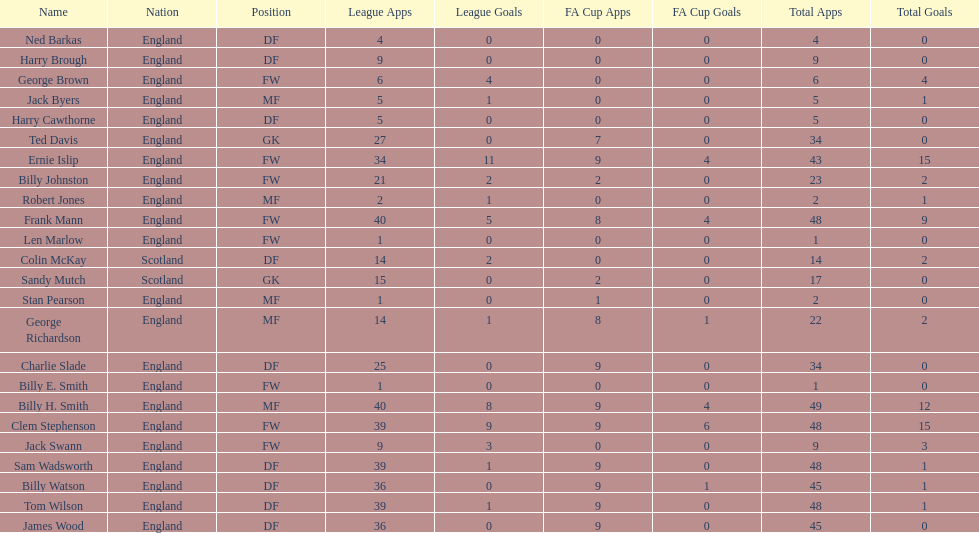Which name appears first in the list? Ned Barkas. 